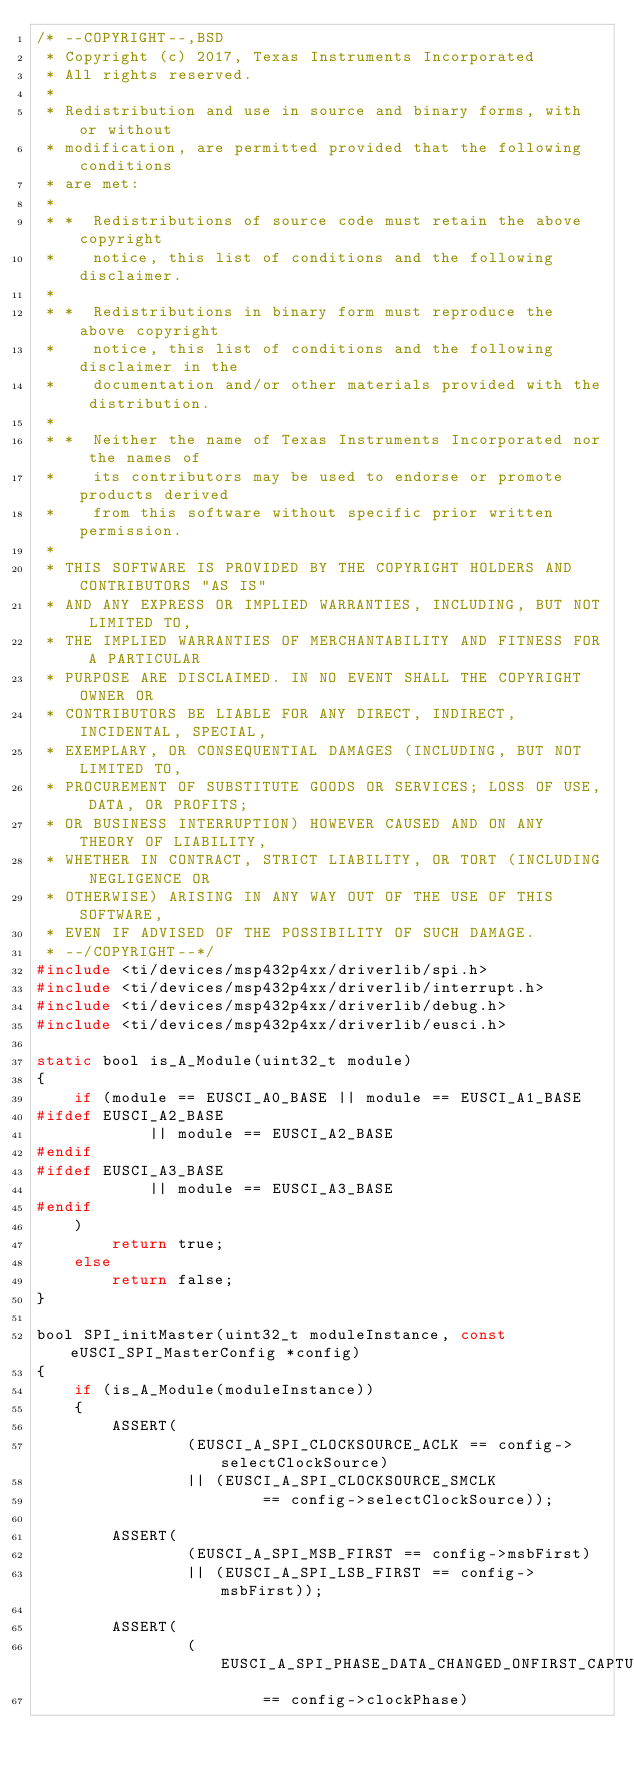Convert code to text. <code><loc_0><loc_0><loc_500><loc_500><_C_>/* --COPYRIGHT--,BSD
 * Copyright (c) 2017, Texas Instruments Incorporated
 * All rights reserved.
 *
 * Redistribution and use in source and binary forms, with or without
 * modification, are permitted provided that the following conditions
 * are met:
 *
 * *  Redistributions of source code must retain the above copyright
 *    notice, this list of conditions and the following disclaimer.
 *
 * *  Redistributions in binary form must reproduce the above copyright
 *    notice, this list of conditions and the following disclaimer in the
 *    documentation and/or other materials provided with the distribution.
 *
 * *  Neither the name of Texas Instruments Incorporated nor the names of
 *    its contributors may be used to endorse or promote products derived
 *    from this software without specific prior written permission.
 *
 * THIS SOFTWARE IS PROVIDED BY THE COPYRIGHT HOLDERS AND CONTRIBUTORS "AS IS"
 * AND ANY EXPRESS OR IMPLIED WARRANTIES, INCLUDING, BUT NOT LIMITED TO,
 * THE IMPLIED WARRANTIES OF MERCHANTABILITY AND FITNESS FOR A PARTICULAR
 * PURPOSE ARE DISCLAIMED. IN NO EVENT SHALL THE COPYRIGHT OWNER OR
 * CONTRIBUTORS BE LIABLE FOR ANY DIRECT, INDIRECT, INCIDENTAL, SPECIAL,
 * EXEMPLARY, OR CONSEQUENTIAL DAMAGES (INCLUDING, BUT NOT LIMITED TO,
 * PROCUREMENT OF SUBSTITUTE GOODS OR SERVICES; LOSS OF USE, DATA, OR PROFITS;
 * OR BUSINESS INTERRUPTION) HOWEVER CAUSED AND ON ANY THEORY OF LIABILITY,
 * WHETHER IN CONTRACT, STRICT LIABILITY, OR TORT (INCLUDING NEGLIGENCE OR
 * OTHERWISE) ARISING IN ANY WAY OUT OF THE USE OF THIS SOFTWARE,
 * EVEN IF ADVISED OF THE POSSIBILITY OF SUCH DAMAGE.
 * --/COPYRIGHT--*/
#include <ti/devices/msp432p4xx/driverlib/spi.h>
#include <ti/devices/msp432p4xx/driverlib/interrupt.h>
#include <ti/devices/msp432p4xx/driverlib/debug.h>
#include <ti/devices/msp432p4xx/driverlib/eusci.h>

static bool is_A_Module(uint32_t module)
{
    if (module == EUSCI_A0_BASE || module == EUSCI_A1_BASE
#ifdef EUSCI_A2_BASE
            || module == EUSCI_A2_BASE
#endif
#ifdef EUSCI_A3_BASE
            || module == EUSCI_A3_BASE
#endif
    )
        return true;
    else
        return false;
}

bool SPI_initMaster(uint32_t moduleInstance, const eUSCI_SPI_MasterConfig *config)
{
    if (is_A_Module(moduleInstance))
    {
        ASSERT(
                (EUSCI_A_SPI_CLOCKSOURCE_ACLK == config->selectClockSource)
                || (EUSCI_A_SPI_CLOCKSOURCE_SMCLK
                        == config->selectClockSource));

        ASSERT(
                (EUSCI_A_SPI_MSB_FIRST == config->msbFirst)
                || (EUSCI_A_SPI_LSB_FIRST == config->msbFirst));

        ASSERT(
                (EUSCI_A_SPI_PHASE_DATA_CHANGED_ONFIRST_CAPTURED_ON_NEXT
                        == config->clockPhase)</code> 